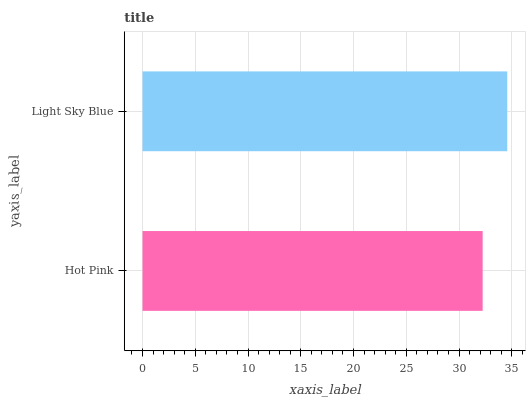Is Hot Pink the minimum?
Answer yes or no. Yes. Is Light Sky Blue the maximum?
Answer yes or no. Yes. Is Light Sky Blue the minimum?
Answer yes or no. No. Is Light Sky Blue greater than Hot Pink?
Answer yes or no. Yes. Is Hot Pink less than Light Sky Blue?
Answer yes or no. Yes. Is Hot Pink greater than Light Sky Blue?
Answer yes or no. No. Is Light Sky Blue less than Hot Pink?
Answer yes or no. No. Is Light Sky Blue the high median?
Answer yes or no. Yes. Is Hot Pink the low median?
Answer yes or no. Yes. Is Hot Pink the high median?
Answer yes or no. No. Is Light Sky Blue the low median?
Answer yes or no. No. 